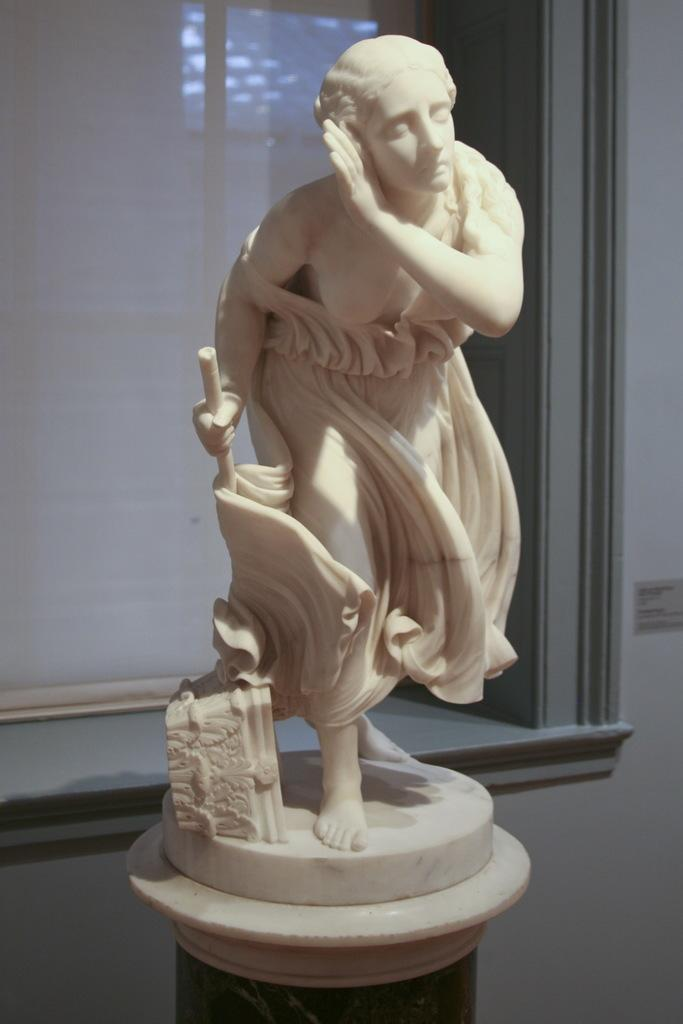What is the main subject of the image? There is a statue in the image. Where is the statue located? The statue is on a platform. What can be seen in the background of the image? There is a wall and a window in the background of the image. Is there any window treatment present in the image? Yes, there is a curtain associated with the window. What type of thread is being used to sew the cushion in the image? There is no cushion present in the image, so it is not possible to determine what type of thread might be used. 